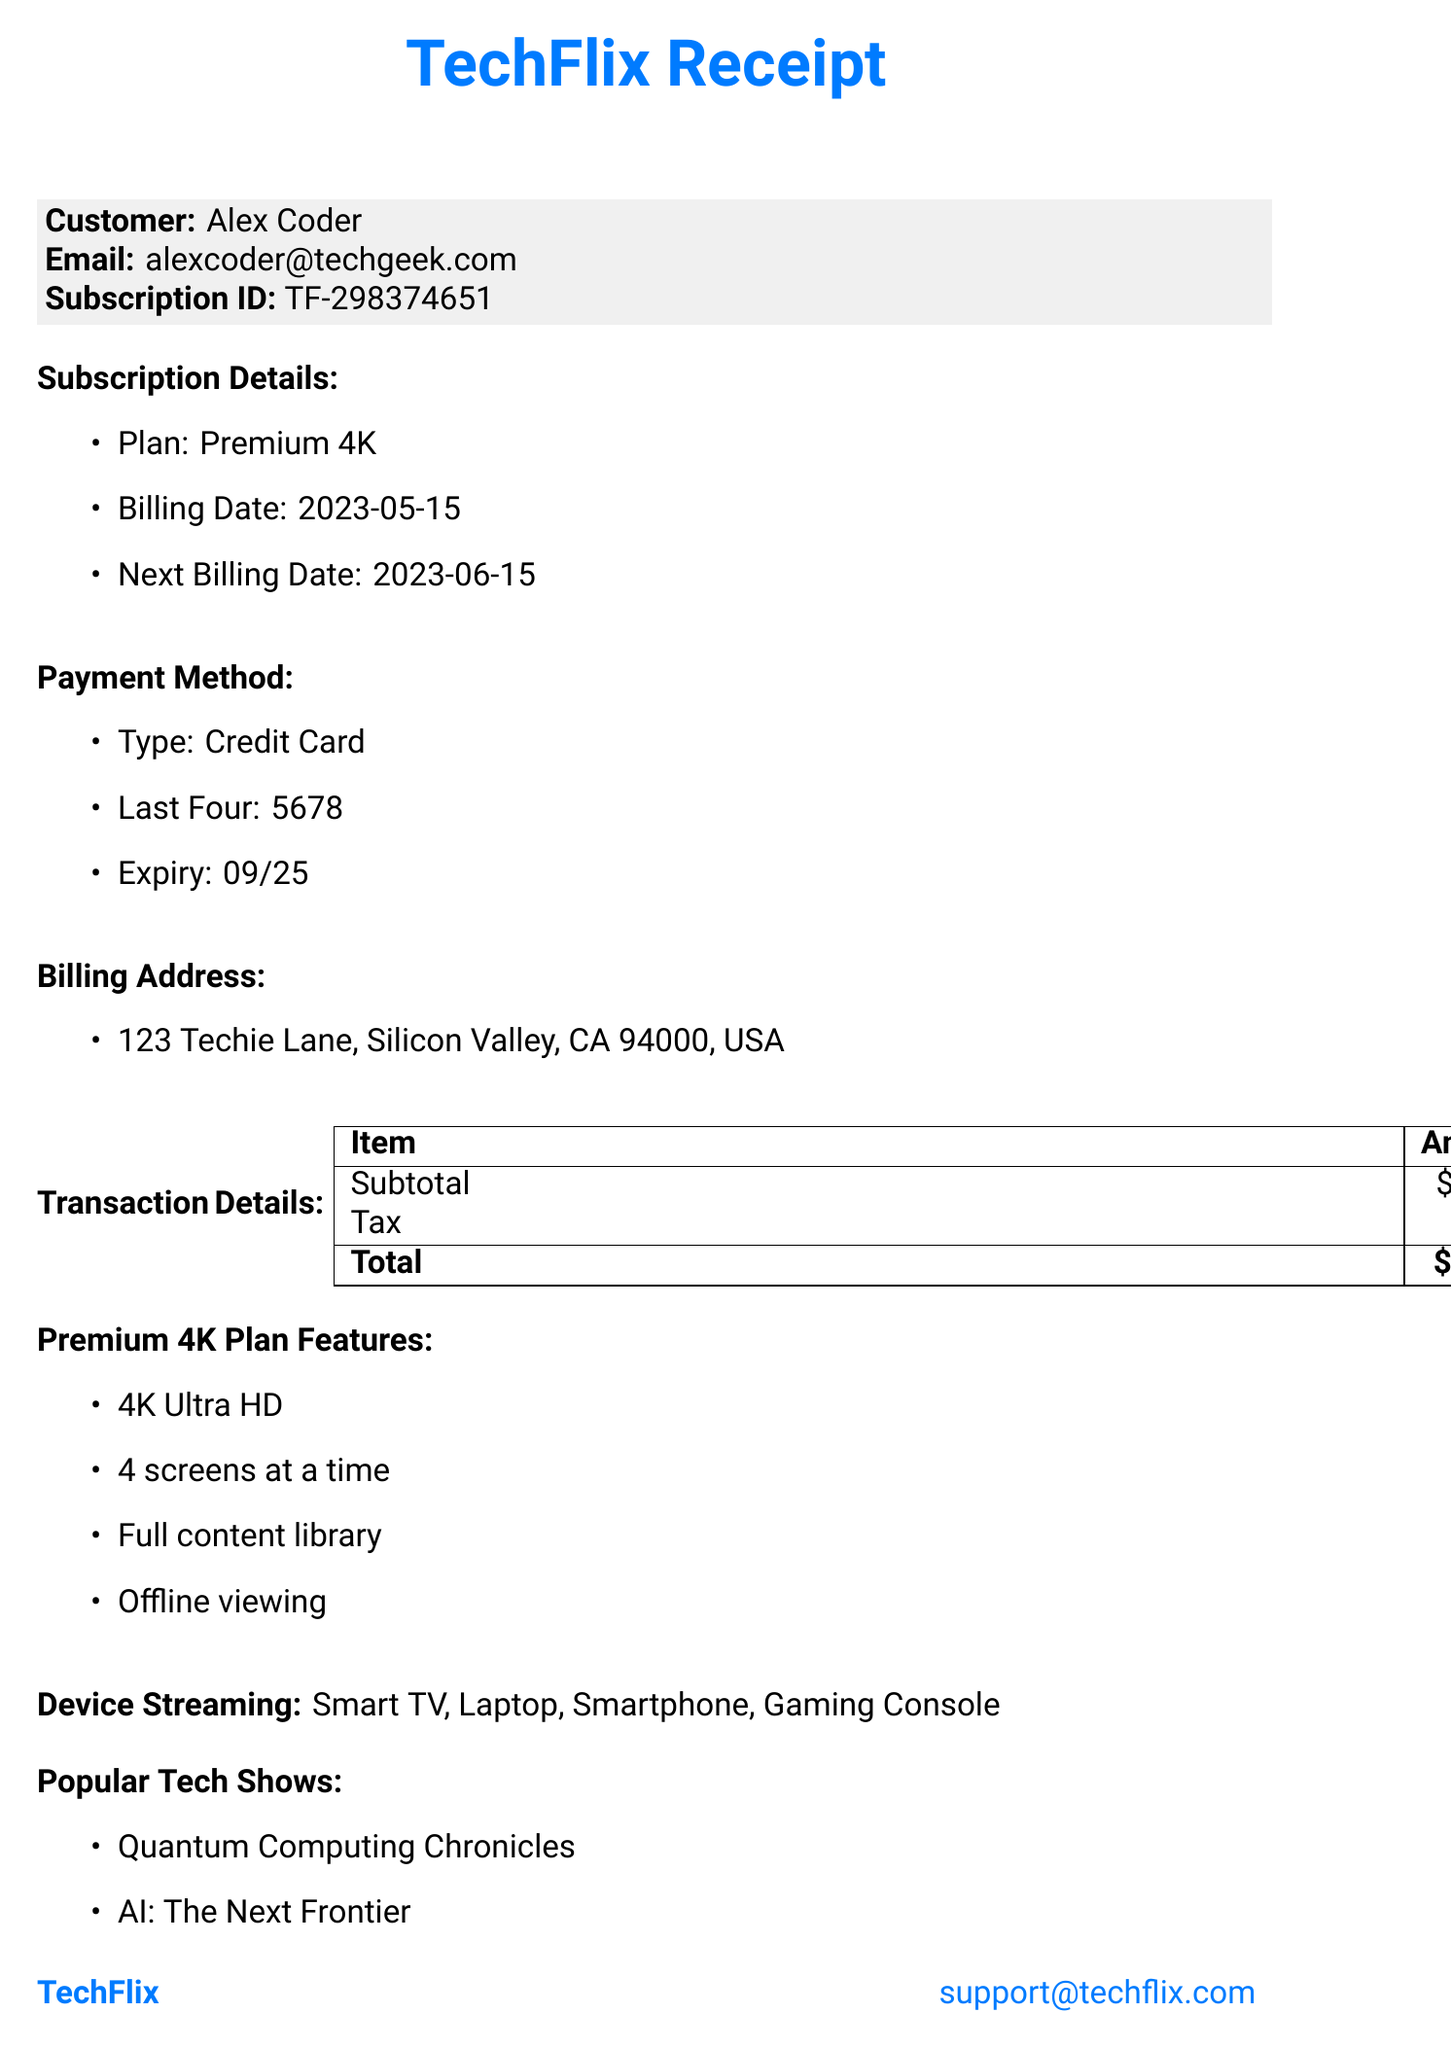What is the name of the streaming service? The name of the streaming service is mentioned in the document as TechFlix.
Answer: TechFlix What is the customer's email address? The customer's email address is provided in the billing information section of the document.
Answer: alexcoder@techgeek.com What plan is the customer subscribed to? The subscription plan is explicitly stated in the subscription details section of the document.
Answer: Premium 4K What is the next billing date? The next billing date can be easily located under the subscription details section in the document.
Answer: 2023-06-15 How much is the total amount charged? The total amount charged is calculated and presented in the transaction details section of the document.
Answer: 19.43 What features are included in the Premium 4K plan? The features of the Premium 4K plan are listed under the Premium 4K Plan Features section of the document.
Answer: 4K Ultra HD, 4 screens at a time, Full content library, Offline viewing How many devices can stream simultaneously under the Premium 4K plan? The number of screens available for streaming is directly mentioned in the features of the subscription plan.
Answer: 4 screens What is the subtotal before tax? The subtotal before tax is outlined in the transaction details portion of the document.
Answer: 17.99 What type of payment method is used? The type of payment method is stated clearly in the payment method section of the document.
Answer: Credit Card 